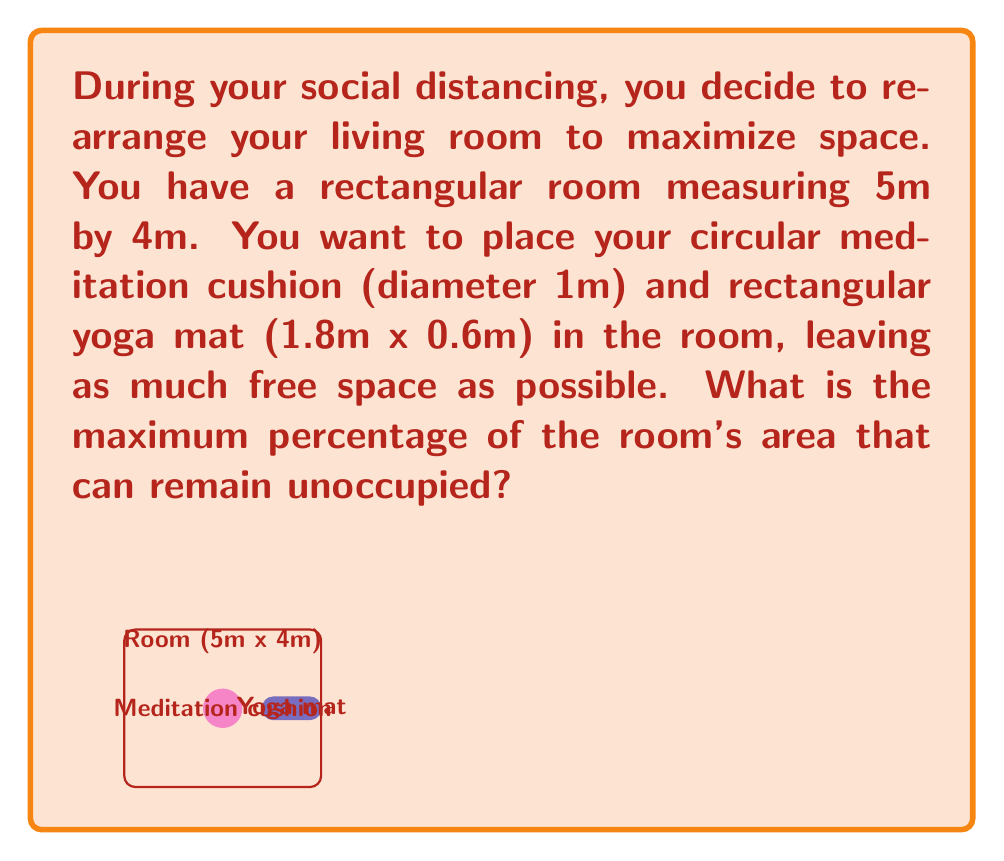Could you help me with this problem? Let's approach this step-by-step:

1) First, calculate the total area of the room:
   $A_{room} = 5m \times 4m = 20m^2$

2) Now, calculate the area of the meditation cushion:
   $A_{cushion} = \pi r^2 = \pi (0.5m)^2 = 0.25\pi m^2$

3) Calculate the area of the yoga mat:
   $A_{mat} = 1.8m \times 0.6m = 1.08m^2$

4) The total area occupied by the furniture is:
   $A_{furniture} = A_{cushion} + A_{mat} = 0.25\pi m^2 + 1.08m^2$

5) The unoccupied area is:
   $A_{unoccupied} = A_{room} - A_{furniture} = 20m^2 - (0.25\pi m^2 + 1.08m^2)$

6) To calculate the percentage, we divide the unoccupied area by the total room area and multiply by 100:

   $\text{Percentage unoccupied} = \frac{A_{unoccupied}}{A_{room}} \times 100\%$

   $= \frac{20 - (0.25\pi + 1.08)}{20} \times 100\%$

   $= (1 - \frac{0.25\pi + 1.08}{20}) \times 100\%$

   $\approx 90.57\%$

Thus, approximately 90.57% of the room can remain unoccupied.
Answer: 90.57% 